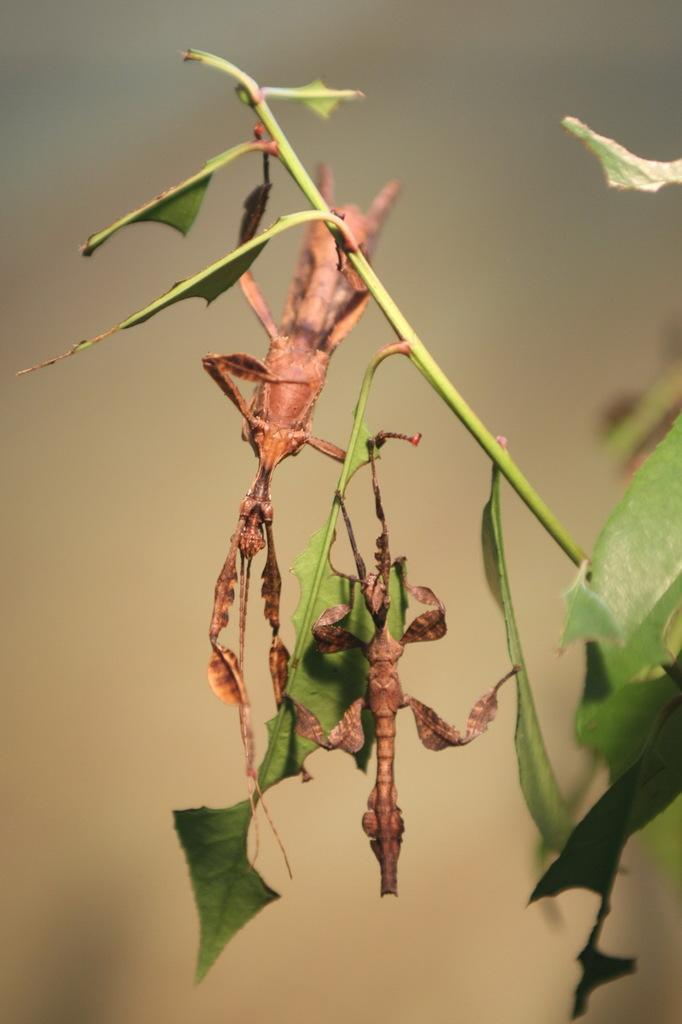What type of creatures can be seen in the image? There are insects in the picture. What is the insects' proximity to in the image? The insects are near steam. Can you describe the background of the image? The background of the image is blurred. What time of day is it in the image, specifically in the afternoon? The time of day is not mentioned or indicated in the image, so it cannot be determined if it is specifically in the afternoon. 